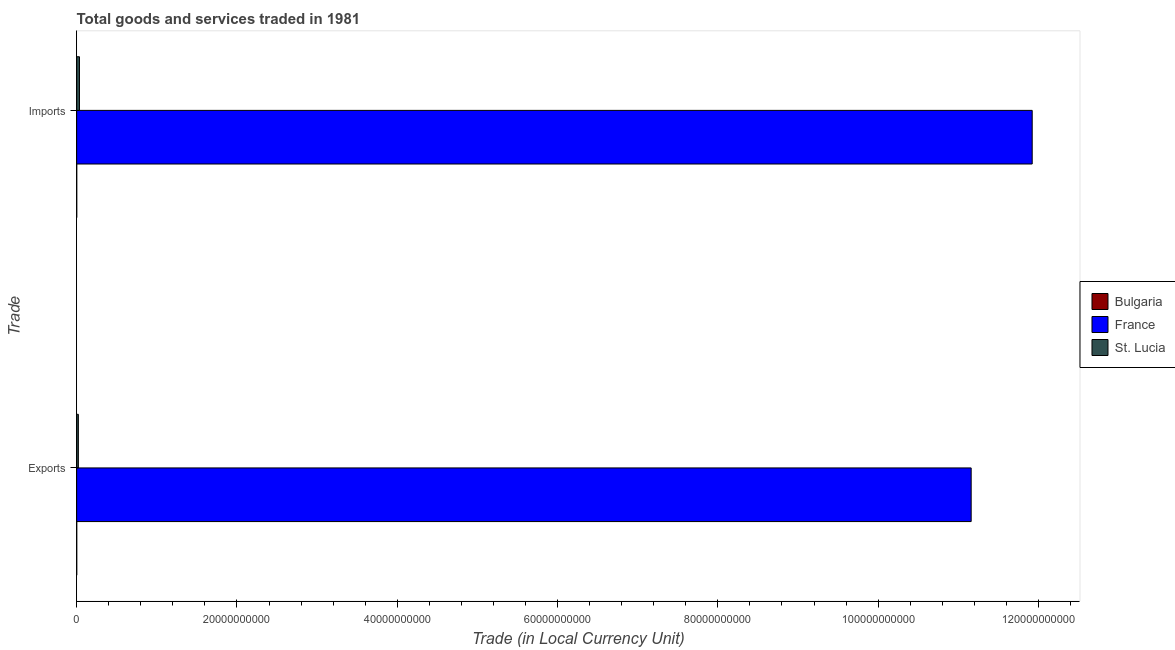How many groups of bars are there?
Offer a terse response. 2. Are the number of bars per tick equal to the number of legend labels?
Make the answer very short. Yes. Are the number of bars on each tick of the Y-axis equal?
Your response must be concise. Yes. What is the label of the 1st group of bars from the top?
Your answer should be compact. Imports. What is the export of goods and services in St. Lucia?
Provide a short and direct response. 2.13e+08. Across all countries, what is the maximum imports of goods and services?
Ensure brevity in your answer.  1.19e+11. Across all countries, what is the minimum export of goods and services?
Make the answer very short. 9.91e+06. In which country was the export of goods and services minimum?
Offer a terse response. Bulgaria. What is the total export of goods and services in the graph?
Provide a succinct answer. 1.12e+11. What is the difference between the imports of goods and services in Bulgaria and that in St. Lucia?
Keep it short and to the point. -3.42e+08. What is the difference between the export of goods and services in France and the imports of goods and services in Bulgaria?
Your answer should be compact. 1.12e+11. What is the average imports of goods and services per country?
Ensure brevity in your answer.  3.99e+1. What is the difference between the imports of goods and services and export of goods and services in France?
Offer a very short reply. 7.62e+09. What is the ratio of the imports of goods and services in France to that in St. Lucia?
Make the answer very short. 339.49. In how many countries, is the export of goods and services greater than the average export of goods and services taken over all countries?
Provide a short and direct response. 1. What does the 3rd bar from the top in Imports represents?
Your answer should be very brief. Bulgaria. How many bars are there?
Provide a short and direct response. 6. What is the difference between two consecutive major ticks on the X-axis?
Your response must be concise. 2.00e+1. How are the legend labels stacked?
Ensure brevity in your answer.  Vertical. What is the title of the graph?
Offer a very short reply. Total goods and services traded in 1981. Does "Kosovo" appear as one of the legend labels in the graph?
Your answer should be compact. No. What is the label or title of the X-axis?
Your answer should be compact. Trade (in Local Currency Unit). What is the label or title of the Y-axis?
Keep it short and to the point. Trade. What is the Trade (in Local Currency Unit) in Bulgaria in Exports?
Keep it short and to the point. 9.91e+06. What is the Trade (in Local Currency Unit) of France in Exports?
Offer a terse response. 1.12e+11. What is the Trade (in Local Currency Unit) of St. Lucia in Exports?
Ensure brevity in your answer.  2.13e+08. What is the Trade (in Local Currency Unit) in Bulgaria in Imports?
Keep it short and to the point. 9.60e+06. What is the Trade (in Local Currency Unit) of France in Imports?
Offer a very short reply. 1.19e+11. What is the Trade (in Local Currency Unit) of St. Lucia in Imports?
Provide a succinct answer. 3.51e+08. Across all Trade, what is the maximum Trade (in Local Currency Unit) in Bulgaria?
Your response must be concise. 9.91e+06. Across all Trade, what is the maximum Trade (in Local Currency Unit) of France?
Offer a terse response. 1.19e+11. Across all Trade, what is the maximum Trade (in Local Currency Unit) of St. Lucia?
Make the answer very short. 3.51e+08. Across all Trade, what is the minimum Trade (in Local Currency Unit) of Bulgaria?
Keep it short and to the point. 9.60e+06. Across all Trade, what is the minimum Trade (in Local Currency Unit) of France?
Your answer should be very brief. 1.12e+11. Across all Trade, what is the minimum Trade (in Local Currency Unit) in St. Lucia?
Ensure brevity in your answer.  2.13e+08. What is the total Trade (in Local Currency Unit) of Bulgaria in the graph?
Your answer should be compact. 1.95e+07. What is the total Trade (in Local Currency Unit) in France in the graph?
Make the answer very short. 2.31e+11. What is the total Trade (in Local Currency Unit) of St. Lucia in the graph?
Offer a terse response. 5.64e+08. What is the difference between the Trade (in Local Currency Unit) in Bulgaria in Exports and that in Imports?
Keep it short and to the point. 3.10e+05. What is the difference between the Trade (in Local Currency Unit) in France in Exports and that in Imports?
Give a very brief answer. -7.62e+09. What is the difference between the Trade (in Local Currency Unit) of St. Lucia in Exports and that in Imports?
Keep it short and to the point. -1.38e+08. What is the difference between the Trade (in Local Currency Unit) in Bulgaria in Exports and the Trade (in Local Currency Unit) in France in Imports?
Offer a very short reply. -1.19e+11. What is the difference between the Trade (in Local Currency Unit) in Bulgaria in Exports and the Trade (in Local Currency Unit) in St. Lucia in Imports?
Keep it short and to the point. -3.41e+08. What is the difference between the Trade (in Local Currency Unit) in France in Exports and the Trade (in Local Currency Unit) in St. Lucia in Imports?
Ensure brevity in your answer.  1.11e+11. What is the average Trade (in Local Currency Unit) of Bulgaria per Trade?
Give a very brief answer. 9.76e+06. What is the average Trade (in Local Currency Unit) in France per Trade?
Make the answer very short. 1.15e+11. What is the average Trade (in Local Currency Unit) in St. Lucia per Trade?
Provide a succinct answer. 2.82e+08. What is the difference between the Trade (in Local Currency Unit) in Bulgaria and Trade (in Local Currency Unit) in France in Exports?
Ensure brevity in your answer.  -1.12e+11. What is the difference between the Trade (in Local Currency Unit) in Bulgaria and Trade (in Local Currency Unit) in St. Lucia in Exports?
Offer a very short reply. -2.03e+08. What is the difference between the Trade (in Local Currency Unit) of France and Trade (in Local Currency Unit) of St. Lucia in Exports?
Offer a very short reply. 1.11e+11. What is the difference between the Trade (in Local Currency Unit) in Bulgaria and Trade (in Local Currency Unit) in France in Imports?
Your answer should be compact. -1.19e+11. What is the difference between the Trade (in Local Currency Unit) of Bulgaria and Trade (in Local Currency Unit) of St. Lucia in Imports?
Your answer should be very brief. -3.42e+08. What is the difference between the Trade (in Local Currency Unit) of France and Trade (in Local Currency Unit) of St. Lucia in Imports?
Provide a short and direct response. 1.19e+11. What is the ratio of the Trade (in Local Currency Unit) of Bulgaria in Exports to that in Imports?
Your response must be concise. 1.03. What is the ratio of the Trade (in Local Currency Unit) in France in Exports to that in Imports?
Provide a succinct answer. 0.94. What is the ratio of the Trade (in Local Currency Unit) in St. Lucia in Exports to that in Imports?
Make the answer very short. 0.61. What is the difference between the highest and the second highest Trade (in Local Currency Unit) in Bulgaria?
Your answer should be compact. 3.10e+05. What is the difference between the highest and the second highest Trade (in Local Currency Unit) of France?
Keep it short and to the point. 7.62e+09. What is the difference between the highest and the second highest Trade (in Local Currency Unit) of St. Lucia?
Your answer should be compact. 1.38e+08. What is the difference between the highest and the lowest Trade (in Local Currency Unit) in Bulgaria?
Your answer should be very brief. 3.10e+05. What is the difference between the highest and the lowest Trade (in Local Currency Unit) of France?
Your response must be concise. 7.62e+09. What is the difference between the highest and the lowest Trade (in Local Currency Unit) of St. Lucia?
Ensure brevity in your answer.  1.38e+08. 